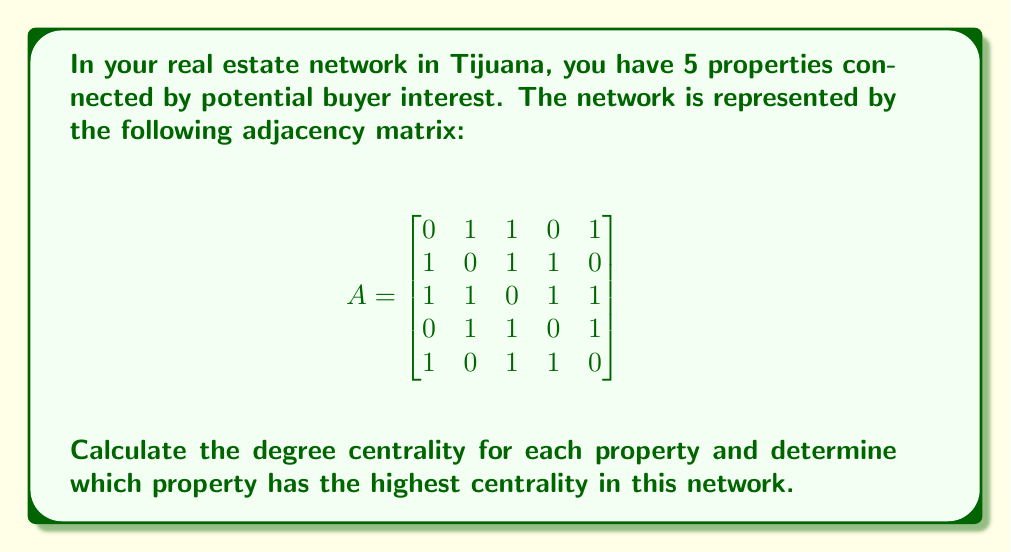Solve this math problem. To solve this problem, we'll follow these steps:

1. Understand degree centrality:
   Degree centrality is a measure of the number of connections a node (in this case, a property) has in the network. It's calculated by summing the row or column of the adjacency matrix for each node.

2. Calculate degree centrality for each property:
   For each row in the adjacency matrix, we'll sum the values to get the degree centrality.

   Property 1: $0 + 1 + 1 + 0 + 1 = 3$
   Property 2: $1 + 0 + 1 + 1 + 0 = 3$
   Property 3: $1 + 1 + 0 + 1 + 1 = 4$
   Property 4: $0 + 1 + 1 + 0 + 1 = 3$
   Property 5: $1 + 0 + 1 + 1 + 0 = 3$

3. Identify the property with the highest centrality:
   Property 3 has the highest degree centrality with a value of 4.

4. Interpret the results:
   In the context of real estate, the property with the highest degree centrality (Property 3) is connected to the most other properties in terms of shared buyer interest. This suggests that Property 3 is the most central or influential in the network, potentially attracting the most diverse range of buyers or serving as a hub for buyer interest in the area.
Answer: Property 3 has the highest degree centrality with a value of 4, making it the most central property in the network. 